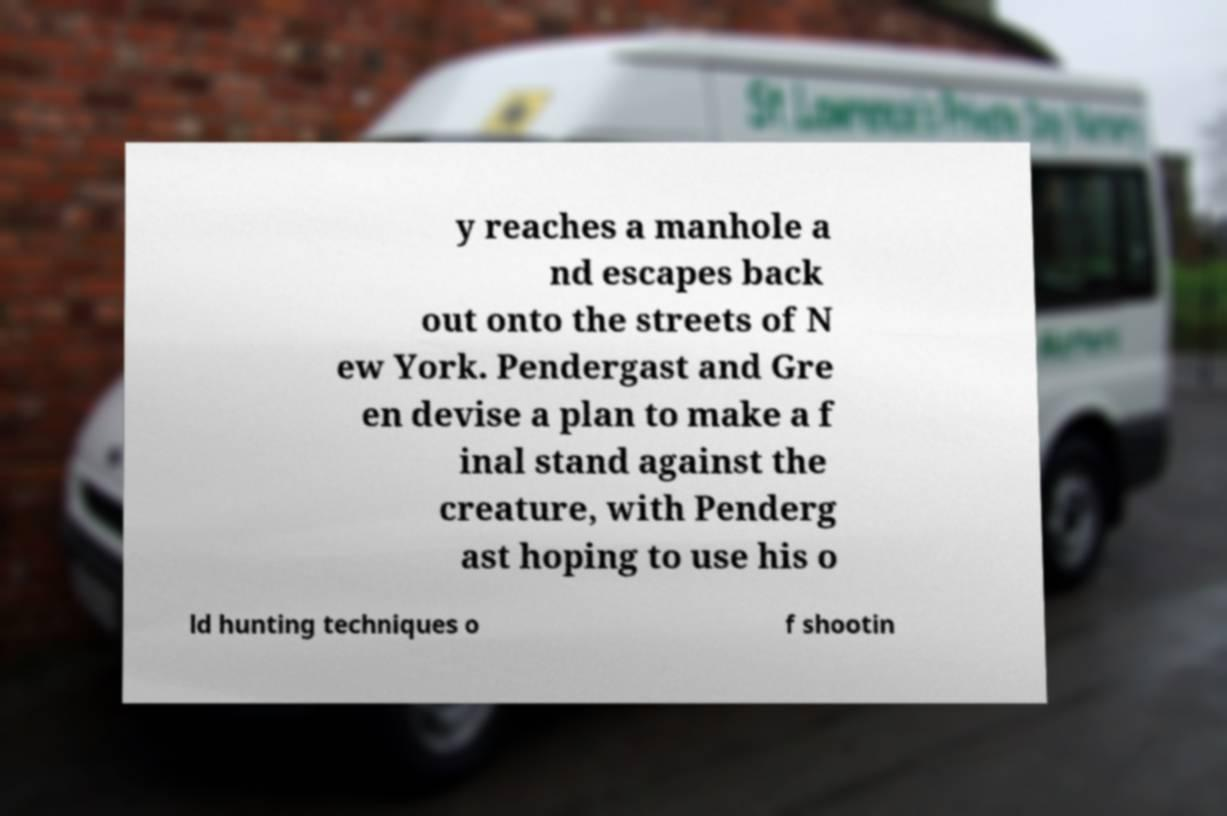For documentation purposes, I need the text within this image transcribed. Could you provide that? y reaches a manhole a nd escapes back out onto the streets of N ew York. Pendergast and Gre en devise a plan to make a f inal stand against the creature, with Penderg ast hoping to use his o ld hunting techniques o f shootin 